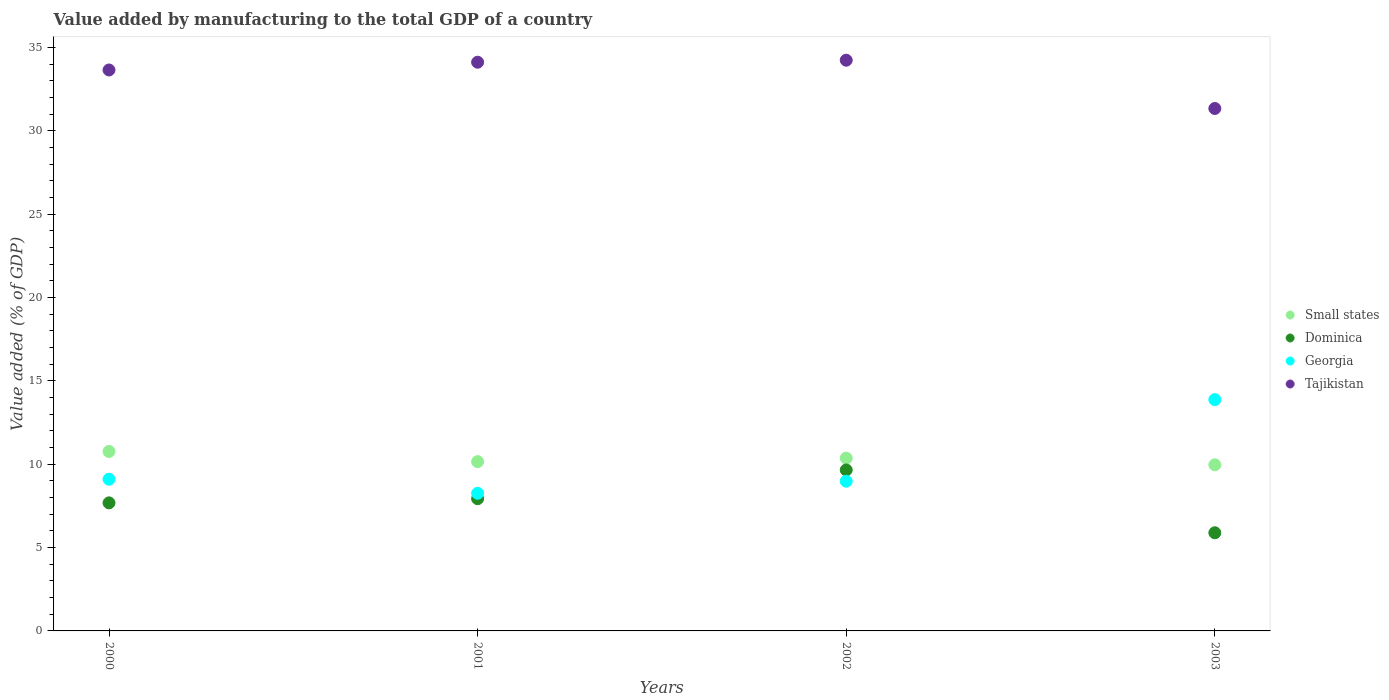How many different coloured dotlines are there?
Give a very brief answer. 4. What is the value added by manufacturing to the total GDP in Tajikistan in 2003?
Make the answer very short. 31.35. Across all years, what is the maximum value added by manufacturing to the total GDP in Small states?
Give a very brief answer. 10.77. Across all years, what is the minimum value added by manufacturing to the total GDP in Georgia?
Keep it short and to the point. 8.26. In which year was the value added by manufacturing to the total GDP in Georgia maximum?
Provide a succinct answer. 2003. What is the total value added by manufacturing to the total GDP in Dominica in the graph?
Offer a very short reply. 31.16. What is the difference between the value added by manufacturing to the total GDP in Georgia in 2000 and that in 2003?
Your response must be concise. -4.78. What is the difference between the value added by manufacturing to the total GDP in Dominica in 2002 and the value added by manufacturing to the total GDP in Tajikistan in 2003?
Keep it short and to the point. -21.69. What is the average value added by manufacturing to the total GDP in Tajikistan per year?
Provide a short and direct response. 33.34. In the year 2002, what is the difference between the value added by manufacturing to the total GDP in Tajikistan and value added by manufacturing to the total GDP in Small states?
Your answer should be compact. 23.88. What is the ratio of the value added by manufacturing to the total GDP in Tajikistan in 2001 to that in 2003?
Ensure brevity in your answer.  1.09. Is the value added by manufacturing to the total GDP in Georgia in 2001 less than that in 2002?
Your answer should be very brief. Yes. Is the difference between the value added by manufacturing to the total GDP in Tajikistan in 2002 and 2003 greater than the difference between the value added by manufacturing to the total GDP in Small states in 2002 and 2003?
Your answer should be compact. Yes. What is the difference between the highest and the second highest value added by manufacturing to the total GDP in Dominica?
Your answer should be very brief. 1.72. What is the difference between the highest and the lowest value added by manufacturing to the total GDP in Tajikistan?
Offer a very short reply. 2.9. Is the sum of the value added by manufacturing to the total GDP in Small states in 2000 and 2003 greater than the maximum value added by manufacturing to the total GDP in Georgia across all years?
Keep it short and to the point. Yes. Does the value added by manufacturing to the total GDP in Georgia monotonically increase over the years?
Ensure brevity in your answer.  No. Is the value added by manufacturing to the total GDP in Dominica strictly less than the value added by manufacturing to the total GDP in Tajikistan over the years?
Keep it short and to the point. Yes. How many dotlines are there?
Ensure brevity in your answer.  4. How many years are there in the graph?
Provide a short and direct response. 4. What is the difference between two consecutive major ticks on the Y-axis?
Give a very brief answer. 5. Are the values on the major ticks of Y-axis written in scientific E-notation?
Offer a very short reply. No. Does the graph contain any zero values?
Offer a very short reply. No. Does the graph contain grids?
Give a very brief answer. No. Where does the legend appear in the graph?
Your answer should be very brief. Center right. What is the title of the graph?
Offer a terse response. Value added by manufacturing to the total GDP of a country. Does "Turks and Caicos Islands" appear as one of the legend labels in the graph?
Your answer should be compact. No. What is the label or title of the Y-axis?
Offer a terse response. Value added (% of GDP). What is the Value added (% of GDP) in Small states in 2000?
Give a very brief answer. 10.77. What is the Value added (% of GDP) in Dominica in 2000?
Offer a terse response. 7.68. What is the Value added (% of GDP) of Georgia in 2000?
Your answer should be very brief. 9.1. What is the Value added (% of GDP) in Tajikistan in 2000?
Make the answer very short. 33.66. What is the Value added (% of GDP) in Small states in 2001?
Ensure brevity in your answer.  10.16. What is the Value added (% of GDP) of Dominica in 2001?
Make the answer very short. 7.93. What is the Value added (% of GDP) in Georgia in 2001?
Your response must be concise. 8.26. What is the Value added (% of GDP) in Tajikistan in 2001?
Provide a succinct answer. 34.12. What is the Value added (% of GDP) in Small states in 2002?
Provide a short and direct response. 10.37. What is the Value added (% of GDP) of Dominica in 2002?
Offer a terse response. 9.66. What is the Value added (% of GDP) in Georgia in 2002?
Offer a terse response. 8.98. What is the Value added (% of GDP) of Tajikistan in 2002?
Your answer should be compact. 34.24. What is the Value added (% of GDP) in Small states in 2003?
Your response must be concise. 9.97. What is the Value added (% of GDP) in Dominica in 2003?
Make the answer very short. 5.89. What is the Value added (% of GDP) in Georgia in 2003?
Offer a terse response. 13.88. What is the Value added (% of GDP) in Tajikistan in 2003?
Provide a short and direct response. 31.35. Across all years, what is the maximum Value added (% of GDP) in Small states?
Your answer should be very brief. 10.77. Across all years, what is the maximum Value added (% of GDP) in Dominica?
Provide a succinct answer. 9.66. Across all years, what is the maximum Value added (% of GDP) in Georgia?
Provide a succinct answer. 13.88. Across all years, what is the maximum Value added (% of GDP) in Tajikistan?
Offer a very short reply. 34.24. Across all years, what is the minimum Value added (% of GDP) in Small states?
Ensure brevity in your answer.  9.97. Across all years, what is the minimum Value added (% of GDP) in Dominica?
Make the answer very short. 5.89. Across all years, what is the minimum Value added (% of GDP) of Georgia?
Your answer should be very brief. 8.26. Across all years, what is the minimum Value added (% of GDP) of Tajikistan?
Make the answer very short. 31.35. What is the total Value added (% of GDP) of Small states in the graph?
Give a very brief answer. 41.26. What is the total Value added (% of GDP) of Dominica in the graph?
Make the answer very short. 31.16. What is the total Value added (% of GDP) of Georgia in the graph?
Ensure brevity in your answer.  40.22. What is the total Value added (% of GDP) in Tajikistan in the graph?
Give a very brief answer. 133.37. What is the difference between the Value added (% of GDP) of Small states in 2000 and that in 2001?
Make the answer very short. 0.61. What is the difference between the Value added (% of GDP) in Dominica in 2000 and that in 2001?
Keep it short and to the point. -0.25. What is the difference between the Value added (% of GDP) in Georgia in 2000 and that in 2001?
Provide a succinct answer. 0.84. What is the difference between the Value added (% of GDP) of Tajikistan in 2000 and that in 2001?
Your answer should be very brief. -0.47. What is the difference between the Value added (% of GDP) of Small states in 2000 and that in 2002?
Ensure brevity in your answer.  0.4. What is the difference between the Value added (% of GDP) in Dominica in 2000 and that in 2002?
Provide a succinct answer. -1.97. What is the difference between the Value added (% of GDP) of Georgia in 2000 and that in 2002?
Your response must be concise. 0.12. What is the difference between the Value added (% of GDP) in Tajikistan in 2000 and that in 2002?
Your answer should be compact. -0.59. What is the difference between the Value added (% of GDP) of Small states in 2000 and that in 2003?
Provide a succinct answer. 0.8. What is the difference between the Value added (% of GDP) in Dominica in 2000 and that in 2003?
Offer a very short reply. 1.79. What is the difference between the Value added (% of GDP) in Georgia in 2000 and that in 2003?
Make the answer very short. -4.78. What is the difference between the Value added (% of GDP) in Tajikistan in 2000 and that in 2003?
Your answer should be compact. 2.31. What is the difference between the Value added (% of GDP) in Small states in 2001 and that in 2002?
Offer a terse response. -0.21. What is the difference between the Value added (% of GDP) in Dominica in 2001 and that in 2002?
Provide a short and direct response. -1.73. What is the difference between the Value added (% of GDP) in Georgia in 2001 and that in 2002?
Ensure brevity in your answer.  -0.72. What is the difference between the Value added (% of GDP) of Tajikistan in 2001 and that in 2002?
Your answer should be very brief. -0.12. What is the difference between the Value added (% of GDP) of Small states in 2001 and that in 2003?
Make the answer very short. 0.19. What is the difference between the Value added (% of GDP) in Dominica in 2001 and that in 2003?
Provide a short and direct response. 2.04. What is the difference between the Value added (% of GDP) in Georgia in 2001 and that in 2003?
Give a very brief answer. -5.62. What is the difference between the Value added (% of GDP) of Tajikistan in 2001 and that in 2003?
Provide a short and direct response. 2.78. What is the difference between the Value added (% of GDP) of Small states in 2002 and that in 2003?
Offer a very short reply. 0.4. What is the difference between the Value added (% of GDP) in Dominica in 2002 and that in 2003?
Provide a short and direct response. 3.77. What is the difference between the Value added (% of GDP) of Georgia in 2002 and that in 2003?
Ensure brevity in your answer.  -4.9. What is the difference between the Value added (% of GDP) of Tajikistan in 2002 and that in 2003?
Provide a succinct answer. 2.9. What is the difference between the Value added (% of GDP) of Small states in 2000 and the Value added (% of GDP) of Dominica in 2001?
Offer a very short reply. 2.84. What is the difference between the Value added (% of GDP) in Small states in 2000 and the Value added (% of GDP) in Georgia in 2001?
Your response must be concise. 2.51. What is the difference between the Value added (% of GDP) in Small states in 2000 and the Value added (% of GDP) in Tajikistan in 2001?
Keep it short and to the point. -23.36. What is the difference between the Value added (% of GDP) in Dominica in 2000 and the Value added (% of GDP) in Georgia in 2001?
Your response must be concise. -0.58. What is the difference between the Value added (% of GDP) of Dominica in 2000 and the Value added (% of GDP) of Tajikistan in 2001?
Provide a short and direct response. -26.44. What is the difference between the Value added (% of GDP) of Georgia in 2000 and the Value added (% of GDP) of Tajikistan in 2001?
Ensure brevity in your answer.  -25.02. What is the difference between the Value added (% of GDP) of Small states in 2000 and the Value added (% of GDP) of Dominica in 2002?
Give a very brief answer. 1.11. What is the difference between the Value added (% of GDP) of Small states in 2000 and the Value added (% of GDP) of Georgia in 2002?
Offer a very short reply. 1.79. What is the difference between the Value added (% of GDP) of Small states in 2000 and the Value added (% of GDP) of Tajikistan in 2002?
Provide a short and direct response. -23.48. What is the difference between the Value added (% of GDP) in Dominica in 2000 and the Value added (% of GDP) in Georgia in 2002?
Your answer should be very brief. -1.3. What is the difference between the Value added (% of GDP) of Dominica in 2000 and the Value added (% of GDP) of Tajikistan in 2002?
Offer a terse response. -26.56. What is the difference between the Value added (% of GDP) in Georgia in 2000 and the Value added (% of GDP) in Tajikistan in 2002?
Your response must be concise. -25.14. What is the difference between the Value added (% of GDP) in Small states in 2000 and the Value added (% of GDP) in Dominica in 2003?
Offer a terse response. 4.88. What is the difference between the Value added (% of GDP) of Small states in 2000 and the Value added (% of GDP) of Georgia in 2003?
Your response must be concise. -3.11. What is the difference between the Value added (% of GDP) in Small states in 2000 and the Value added (% of GDP) in Tajikistan in 2003?
Make the answer very short. -20.58. What is the difference between the Value added (% of GDP) of Dominica in 2000 and the Value added (% of GDP) of Georgia in 2003?
Your answer should be very brief. -6.2. What is the difference between the Value added (% of GDP) in Dominica in 2000 and the Value added (% of GDP) in Tajikistan in 2003?
Your response must be concise. -23.66. What is the difference between the Value added (% of GDP) in Georgia in 2000 and the Value added (% of GDP) in Tajikistan in 2003?
Keep it short and to the point. -22.25. What is the difference between the Value added (% of GDP) of Small states in 2001 and the Value added (% of GDP) of Dominica in 2002?
Your answer should be compact. 0.5. What is the difference between the Value added (% of GDP) of Small states in 2001 and the Value added (% of GDP) of Georgia in 2002?
Provide a succinct answer. 1.18. What is the difference between the Value added (% of GDP) of Small states in 2001 and the Value added (% of GDP) of Tajikistan in 2002?
Provide a succinct answer. -24.09. What is the difference between the Value added (% of GDP) of Dominica in 2001 and the Value added (% of GDP) of Georgia in 2002?
Your response must be concise. -1.05. What is the difference between the Value added (% of GDP) in Dominica in 2001 and the Value added (% of GDP) in Tajikistan in 2002?
Your answer should be compact. -26.31. What is the difference between the Value added (% of GDP) of Georgia in 2001 and the Value added (% of GDP) of Tajikistan in 2002?
Ensure brevity in your answer.  -25.98. What is the difference between the Value added (% of GDP) of Small states in 2001 and the Value added (% of GDP) of Dominica in 2003?
Offer a terse response. 4.27. What is the difference between the Value added (% of GDP) of Small states in 2001 and the Value added (% of GDP) of Georgia in 2003?
Your answer should be compact. -3.72. What is the difference between the Value added (% of GDP) of Small states in 2001 and the Value added (% of GDP) of Tajikistan in 2003?
Offer a very short reply. -21.19. What is the difference between the Value added (% of GDP) in Dominica in 2001 and the Value added (% of GDP) in Georgia in 2003?
Offer a very short reply. -5.95. What is the difference between the Value added (% of GDP) of Dominica in 2001 and the Value added (% of GDP) of Tajikistan in 2003?
Your answer should be compact. -23.42. What is the difference between the Value added (% of GDP) of Georgia in 2001 and the Value added (% of GDP) of Tajikistan in 2003?
Offer a terse response. -23.09. What is the difference between the Value added (% of GDP) in Small states in 2002 and the Value added (% of GDP) in Dominica in 2003?
Your response must be concise. 4.48. What is the difference between the Value added (% of GDP) of Small states in 2002 and the Value added (% of GDP) of Georgia in 2003?
Give a very brief answer. -3.51. What is the difference between the Value added (% of GDP) of Small states in 2002 and the Value added (% of GDP) of Tajikistan in 2003?
Your response must be concise. -20.98. What is the difference between the Value added (% of GDP) of Dominica in 2002 and the Value added (% of GDP) of Georgia in 2003?
Offer a terse response. -4.22. What is the difference between the Value added (% of GDP) in Dominica in 2002 and the Value added (% of GDP) in Tajikistan in 2003?
Make the answer very short. -21.69. What is the difference between the Value added (% of GDP) in Georgia in 2002 and the Value added (% of GDP) in Tajikistan in 2003?
Make the answer very short. -22.37. What is the average Value added (% of GDP) in Small states per year?
Give a very brief answer. 10.32. What is the average Value added (% of GDP) of Dominica per year?
Offer a very short reply. 7.79. What is the average Value added (% of GDP) in Georgia per year?
Your answer should be compact. 10.06. What is the average Value added (% of GDP) of Tajikistan per year?
Keep it short and to the point. 33.34. In the year 2000, what is the difference between the Value added (% of GDP) of Small states and Value added (% of GDP) of Dominica?
Keep it short and to the point. 3.08. In the year 2000, what is the difference between the Value added (% of GDP) of Small states and Value added (% of GDP) of Georgia?
Your answer should be compact. 1.67. In the year 2000, what is the difference between the Value added (% of GDP) of Small states and Value added (% of GDP) of Tajikistan?
Your answer should be compact. -22.89. In the year 2000, what is the difference between the Value added (% of GDP) of Dominica and Value added (% of GDP) of Georgia?
Your answer should be very brief. -1.42. In the year 2000, what is the difference between the Value added (% of GDP) of Dominica and Value added (% of GDP) of Tajikistan?
Ensure brevity in your answer.  -25.97. In the year 2000, what is the difference between the Value added (% of GDP) of Georgia and Value added (% of GDP) of Tajikistan?
Make the answer very short. -24.55. In the year 2001, what is the difference between the Value added (% of GDP) of Small states and Value added (% of GDP) of Dominica?
Provide a succinct answer. 2.23. In the year 2001, what is the difference between the Value added (% of GDP) in Small states and Value added (% of GDP) in Georgia?
Ensure brevity in your answer.  1.9. In the year 2001, what is the difference between the Value added (% of GDP) in Small states and Value added (% of GDP) in Tajikistan?
Provide a short and direct response. -23.97. In the year 2001, what is the difference between the Value added (% of GDP) of Dominica and Value added (% of GDP) of Georgia?
Provide a succinct answer. -0.33. In the year 2001, what is the difference between the Value added (% of GDP) in Dominica and Value added (% of GDP) in Tajikistan?
Make the answer very short. -26.19. In the year 2001, what is the difference between the Value added (% of GDP) in Georgia and Value added (% of GDP) in Tajikistan?
Your answer should be very brief. -25.86. In the year 2002, what is the difference between the Value added (% of GDP) in Small states and Value added (% of GDP) in Dominica?
Provide a succinct answer. 0.71. In the year 2002, what is the difference between the Value added (% of GDP) of Small states and Value added (% of GDP) of Georgia?
Your answer should be very brief. 1.39. In the year 2002, what is the difference between the Value added (% of GDP) in Small states and Value added (% of GDP) in Tajikistan?
Provide a succinct answer. -23.88. In the year 2002, what is the difference between the Value added (% of GDP) in Dominica and Value added (% of GDP) in Georgia?
Give a very brief answer. 0.68. In the year 2002, what is the difference between the Value added (% of GDP) of Dominica and Value added (% of GDP) of Tajikistan?
Offer a very short reply. -24.59. In the year 2002, what is the difference between the Value added (% of GDP) in Georgia and Value added (% of GDP) in Tajikistan?
Your response must be concise. -25.26. In the year 2003, what is the difference between the Value added (% of GDP) of Small states and Value added (% of GDP) of Dominica?
Your response must be concise. 4.08. In the year 2003, what is the difference between the Value added (% of GDP) in Small states and Value added (% of GDP) in Georgia?
Give a very brief answer. -3.91. In the year 2003, what is the difference between the Value added (% of GDP) in Small states and Value added (% of GDP) in Tajikistan?
Offer a terse response. -21.38. In the year 2003, what is the difference between the Value added (% of GDP) in Dominica and Value added (% of GDP) in Georgia?
Offer a terse response. -7.99. In the year 2003, what is the difference between the Value added (% of GDP) of Dominica and Value added (% of GDP) of Tajikistan?
Your answer should be compact. -25.46. In the year 2003, what is the difference between the Value added (% of GDP) of Georgia and Value added (% of GDP) of Tajikistan?
Offer a terse response. -17.47. What is the ratio of the Value added (% of GDP) in Small states in 2000 to that in 2001?
Keep it short and to the point. 1.06. What is the ratio of the Value added (% of GDP) of Dominica in 2000 to that in 2001?
Provide a short and direct response. 0.97. What is the ratio of the Value added (% of GDP) of Georgia in 2000 to that in 2001?
Your answer should be compact. 1.1. What is the ratio of the Value added (% of GDP) of Tajikistan in 2000 to that in 2001?
Offer a terse response. 0.99. What is the ratio of the Value added (% of GDP) of Small states in 2000 to that in 2002?
Make the answer very short. 1.04. What is the ratio of the Value added (% of GDP) of Dominica in 2000 to that in 2002?
Offer a very short reply. 0.8. What is the ratio of the Value added (% of GDP) in Georgia in 2000 to that in 2002?
Make the answer very short. 1.01. What is the ratio of the Value added (% of GDP) in Tajikistan in 2000 to that in 2002?
Offer a terse response. 0.98. What is the ratio of the Value added (% of GDP) of Small states in 2000 to that in 2003?
Keep it short and to the point. 1.08. What is the ratio of the Value added (% of GDP) of Dominica in 2000 to that in 2003?
Your response must be concise. 1.3. What is the ratio of the Value added (% of GDP) in Georgia in 2000 to that in 2003?
Provide a short and direct response. 0.66. What is the ratio of the Value added (% of GDP) of Tajikistan in 2000 to that in 2003?
Keep it short and to the point. 1.07. What is the ratio of the Value added (% of GDP) of Small states in 2001 to that in 2002?
Keep it short and to the point. 0.98. What is the ratio of the Value added (% of GDP) in Dominica in 2001 to that in 2002?
Give a very brief answer. 0.82. What is the ratio of the Value added (% of GDP) of Georgia in 2001 to that in 2002?
Provide a short and direct response. 0.92. What is the ratio of the Value added (% of GDP) of Tajikistan in 2001 to that in 2002?
Your response must be concise. 1. What is the ratio of the Value added (% of GDP) of Small states in 2001 to that in 2003?
Ensure brevity in your answer.  1.02. What is the ratio of the Value added (% of GDP) in Dominica in 2001 to that in 2003?
Provide a short and direct response. 1.35. What is the ratio of the Value added (% of GDP) of Georgia in 2001 to that in 2003?
Provide a short and direct response. 0.6. What is the ratio of the Value added (% of GDP) of Tajikistan in 2001 to that in 2003?
Make the answer very short. 1.09. What is the ratio of the Value added (% of GDP) of Small states in 2002 to that in 2003?
Keep it short and to the point. 1.04. What is the ratio of the Value added (% of GDP) in Dominica in 2002 to that in 2003?
Your response must be concise. 1.64. What is the ratio of the Value added (% of GDP) in Georgia in 2002 to that in 2003?
Provide a succinct answer. 0.65. What is the ratio of the Value added (% of GDP) in Tajikistan in 2002 to that in 2003?
Your response must be concise. 1.09. What is the difference between the highest and the second highest Value added (% of GDP) in Small states?
Provide a succinct answer. 0.4. What is the difference between the highest and the second highest Value added (% of GDP) of Dominica?
Your answer should be very brief. 1.73. What is the difference between the highest and the second highest Value added (% of GDP) of Georgia?
Keep it short and to the point. 4.78. What is the difference between the highest and the second highest Value added (% of GDP) of Tajikistan?
Ensure brevity in your answer.  0.12. What is the difference between the highest and the lowest Value added (% of GDP) in Small states?
Give a very brief answer. 0.8. What is the difference between the highest and the lowest Value added (% of GDP) in Dominica?
Provide a succinct answer. 3.77. What is the difference between the highest and the lowest Value added (% of GDP) in Georgia?
Offer a terse response. 5.62. What is the difference between the highest and the lowest Value added (% of GDP) of Tajikistan?
Offer a terse response. 2.9. 